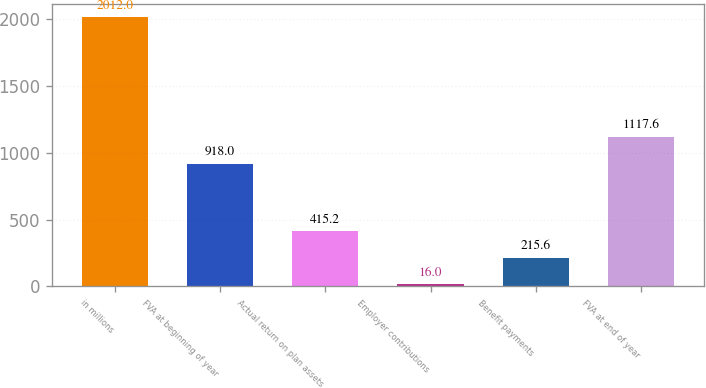Convert chart. <chart><loc_0><loc_0><loc_500><loc_500><bar_chart><fcel>in millions<fcel>FVA at beginning of year<fcel>Actual return on plan assets<fcel>Employer contributions<fcel>Benefit payments<fcel>FVA at end of year<nl><fcel>2012<fcel>918<fcel>415.2<fcel>16<fcel>215.6<fcel>1117.6<nl></chart> 